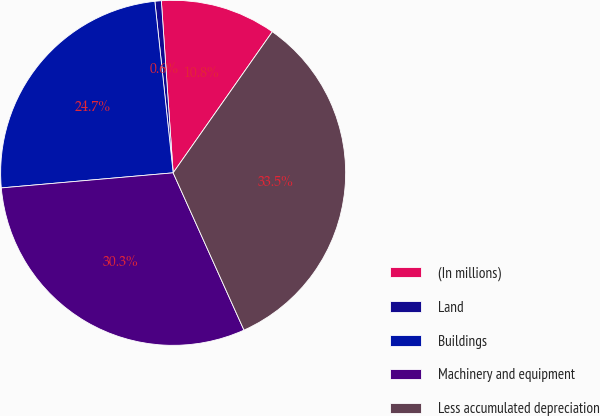Convert chart to OTSL. <chart><loc_0><loc_0><loc_500><loc_500><pie_chart><fcel>(In millions)<fcel>Land<fcel>Buildings<fcel>Machinery and equipment<fcel>Less accumulated depreciation<nl><fcel>10.84%<fcel>0.6%<fcel>24.7%<fcel>30.34%<fcel>33.51%<nl></chart> 